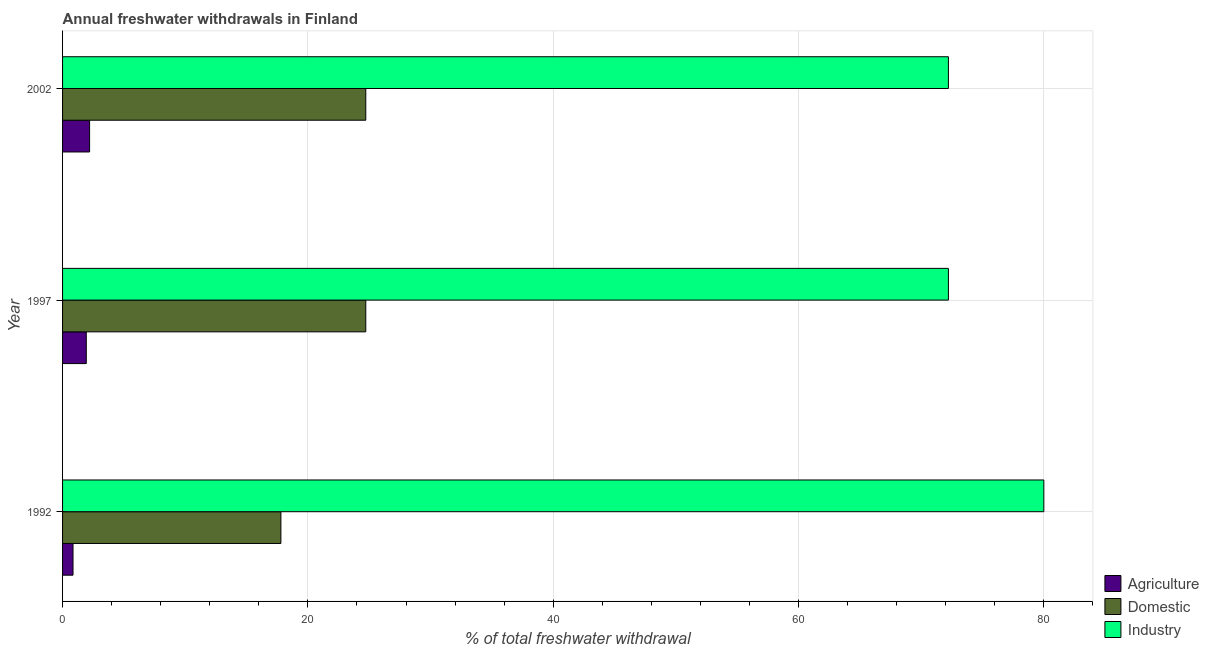How many different coloured bars are there?
Make the answer very short. 3. How many groups of bars are there?
Keep it short and to the point. 3. Are the number of bars on each tick of the Y-axis equal?
Your response must be concise. Yes. How many bars are there on the 1st tick from the top?
Offer a terse response. 3. How many bars are there on the 3rd tick from the bottom?
Give a very brief answer. 3. What is the label of the 1st group of bars from the top?
Provide a short and direct response. 2002. What is the percentage of freshwater withdrawal for agriculture in 1997?
Provide a short and direct response. 1.93. Across all years, what is the maximum percentage of freshwater withdrawal for agriculture?
Provide a succinct answer. 2.2. Across all years, what is the minimum percentage of freshwater withdrawal for domestic purposes?
Provide a short and direct response. 17.8. What is the total percentage of freshwater withdrawal for domestic purposes in the graph?
Offer a very short reply. 67.24. What is the difference between the percentage of freshwater withdrawal for agriculture in 1997 and that in 2002?
Give a very brief answer. -0.27. What is the difference between the percentage of freshwater withdrawal for domestic purposes in 1992 and the percentage of freshwater withdrawal for industry in 1997?
Provide a succinct answer. -54.42. What is the average percentage of freshwater withdrawal for agriculture per year?
Your answer should be very brief. 1.66. In the year 1997, what is the difference between the percentage of freshwater withdrawal for industry and percentage of freshwater withdrawal for domestic purposes?
Give a very brief answer. 47.5. In how many years, is the percentage of freshwater withdrawal for domestic purposes greater than 36 %?
Give a very brief answer. 0. What is the ratio of the percentage of freshwater withdrawal for agriculture in 1997 to that in 2002?
Your answer should be very brief. 0.88. Is the percentage of freshwater withdrawal for industry in 1992 less than that in 2002?
Your answer should be very brief. No. Is the difference between the percentage of freshwater withdrawal for domestic purposes in 1997 and 2002 greater than the difference between the percentage of freshwater withdrawal for industry in 1997 and 2002?
Your response must be concise. No. What is the difference between the highest and the lowest percentage of freshwater withdrawal for industry?
Provide a short and direct response. 7.78. In how many years, is the percentage of freshwater withdrawal for agriculture greater than the average percentage of freshwater withdrawal for agriculture taken over all years?
Keep it short and to the point. 2. Is the sum of the percentage of freshwater withdrawal for domestic purposes in 1992 and 2002 greater than the maximum percentage of freshwater withdrawal for industry across all years?
Keep it short and to the point. No. What does the 2nd bar from the top in 2002 represents?
Make the answer very short. Domestic. What does the 2nd bar from the bottom in 1992 represents?
Your answer should be compact. Domestic. Is it the case that in every year, the sum of the percentage of freshwater withdrawal for agriculture and percentage of freshwater withdrawal for domestic purposes is greater than the percentage of freshwater withdrawal for industry?
Provide a succinct answer. No. How many bars are there?
Your answer should be compact. 9. What is the difference between two consecutive major ticks on the X-axis?
Give a very brief answer. 20. Are the values on the major ticks of X-axis written in scientific E-notation?
Provide a short and direct response. No. How many legend labels are there?
Give a very brief answer. 3. How are the legend labels stacked?
Offer a very short reply. Vertical. What is the title of the graph?
Make the answer very short. Annual freshwater withdrawals in Finland. What is the label or title of the X-axis?
Provide a short and direct response. % of total freshwater withdrawal. What is the % of total freshwater withdrawal of Agriculture in 1992?
Make the answer very short. 0.85. What is the % of total freshwater withdrawal of Industry in 1992?
Offer a terse response. 80. What is the % of total freshwater withdrawal in Agriculture in 1997?
Give a very brief answer. 1.93. What is the % of total freshwater withdrawal of Domestic in 1997?
Your answer should be compact. 24.72. What is the % of total freshwater withdrawal of Industry in 1997?
Keep it short and to the point. 72.22. What is the % of total freshwater withdrawal of Agriculture in 2002?
Your answer should be compact. 2.2. What is the % of total freshwater withdrawal in Domestic in 2002?
Your answer should be compact. 24.72. What is the % of total freshwater withdrawal of Industry in 2002?
Keep it short and to the point. 72.22. Across all years, what is the maximum % of total freshwater withdrawal in Agriculture?
Ensure brevity in your answer.  2.2. Across all years, what is the maximum % of total freshwater withdrawal in Domestic?
Ensure brevity in your answer.  24.72. Across all years, what is the minimum % of total freshwater withdrawal of Agriculture?
Your answer should be compact. 0.85. Across all years, what is the minimum % of total freshwater withdrawal of Domestic?
Keep it short and to the point. 17.8. Across all years, what is the minimum % of total freshwater withdrawal in Industry?
Your answer should be compact. 72.22. What is the total % of total freshwater withdrawal of Agriculture in the graph?
Your answer should be compact. 4.99. What is the total % of total freshwater withdrawal of Domestic in the graph?
Keep it short and to the point. 67.24. What is the total % of total freshwater withdrawal of Industry in the graph?
Keep it short and to the point. 224.44. What is the difference between the % of total freshwater withdrawal of Agriculture in 1992 and that in 1997?
Ensure brevity in your answer.  -1.08. What is the difference between the % of total freshwater withdrawal of Domestic in 1992 and that in 1997?
Provide a succinct answer. -6.92. What is the difference between the % of total freshwater withdrawal of Industry in 1992 and that in 1997?
Provide a succinct answer. 7.78. What is the difference between the % of total freshwater withdrawal in Agriculture in 1992 and that in 2002?
Give a very brief answer. -1.35. What is the difference between the % of total freshwater withdrawal of Domestic in 1992 and that in 2002?
Your response must be concise. -6.92. What is the difference between the % of total freshwater withdrawal in Industry in 1992 and that in 2002?
Give a very brief answer. 7.78. What is the difference between the % of total freshwater withdrawal of Agriculture in 1997 and that in 2002?
Give a very brief answer. -0.27. What is the difference between the % of total freshwater withdrawal of Domestic in 1997 and that in 2002?
Offer a very short reply. 0. What is the difference between the % of total freshwater withdrawal of Industry in 1997 and that in 2002?
Your response must be concise. 0. What is the difference between the % of total freshwater withdrawal of Agriculture in 1992 and the % of total freshwater withdrawal of Domestic in 1997?
Offer a terse response. -23.87. What is the difference between the % of total freshwater withdrawal of Agriculture in 1992 and the % of total freshwater withdrawal of Industry in 1997?
Offer a very short reply. -71.37. What is the difference between the % of total freshwater withdrawal of Domestic in 1992 and the % of total freshwater withdrawal of Industry in 1997?
Offer a very short reply. -54.42. What is the difference between the % of total freshwater withdrawal of Agriculture in 1992 and the % of total freshwater withdrawal of Domestic in 2002?
Offer a very short reply. -23.87. What is the difference between the % of total freshwater withdrawal of Agriculture in 1992 and the % of total freshwater withdrawal of Industry in 2002?
Provide a short and direct response. -71.37. What is the difference between the % of total freshwater withdrawal of Domestic in 1992 and the % of total freshwater withdrawal of Industry in 2002?
Offer a very short reply. -54.42. What is the difference between the % of total freshwater withdrawal of Agriculture in 1997 and the % of total freshwater withdrawal of Domestic in 2002?
Provide a short and direct response. -22.79. What is the difference between the % of total freshwater withdrawal of Agriculture in 1997 and the % of total freshwater withdrawal of Industry in 2002?
Offer a very short reply. -70.29. What is the difference between the % of total freshwater withdrawal in Domestic in 1997 and the % of total freshwater withdrawal in Industry in 2002?
Your answer should be compact. -47.5. What is the average % of total freshwater withdrawal of Agriculture per year?
Give a very brief answer. 1.66. What is the average % of total freshwater withdrawal in Domestic per year?
Provide a succinct answer. 22.41. What is the average % of total freshwater withdrawal in Industry per year?
Provide a succinct answer. 74.81. In the year 1992, what is the difference between the % of total freshwater withdrawal in Agriculture and % of total freshwater withdrawal in Domestic?
Your answer should be compact. -16.95. In the year 1992, what is the difference between the % of total freshwater withdrawal of Agriculture and % of total freshwater withdrawal of Industry?
Give a very brief answer. -79.15. In the year 1992, what is the difference between the % of total freshwater withdrawal in Domestic and % of total freshwater withdrawal in Industry?
Your response must be concise. -62.2. In the year 1997, what is the difference between the % of total freshwater withdrawal of Agriculture and % of total freshwater withdrawal of Domestic?
Your answer should be compact. -22.79. In the year 1997, what is the difference between the % of total freshwater withdrawal of Agriculture and % of total freshwater withdrawal of Industry?
Offer a terse response. -70.29. In the year 1997, what is the difference between the % of total freshwater withdrawal of Domestic and % of total freshwater withdrawal of Industry?
Offer a terse response. -47.5. In the year 2002, what is the difference between the % of total freshwater withdrawal of Agriculture and % of total freshwater withdrawal of Domestic?
Make the answer very short. -22.52. In the year 2002, what is the difference between the % of total freshwater withdrawal of Agriculture and % of total freshwater withdrawal of Industry?
Your answer should be very brief. -70.02. In the year 2002, what is the difference between the % of total freshwater withdrawal in Domestic and % of total freshwater withdrawal in Industry?
Ensure brevity in your answer.  -47.5. What is the ratio of the % of total freshwater withdrawal of Agriculture in 1992 to that in 1997?
Offer a very short reply. 0.44. What is the ratio of the % of total freshwater withdrawal of Domestic in 1992 to that in 1997?
Ensure brevity in your answer.  0.72. What is the ratio of the % of total freshwater withdrawal of Industry in 1992 to that in 1997?
Provide a short and direct response. 1.11. What is the ratio of the % of total freshwater withdrawal in Agriculture in 1992 to that in 2002?
Keep it short and to the point. 0.39. What is the ratio of the % of total freshwater withdrawal in Domestic in 1992 to that in 2002?
Your answer should be very brief. 0.72. What is the ratio of the % of total freshwater withdrawal in Industry in 1992 to that in 2002?
Your answer should be very brief. 1.11. What is the ratio of the % of total freshwater withdrawal of Agriculture in 1997 to that in 2002?
Provide a succinct answer. 0.88. What is the ratio of the % of total freshwater withdrawal of Domestic in 1997 to that in 2002?
Offer a terse response. 1. What is the difference between the highest and the second highest % of total freshwater withdrawal in Agriculture?
Keep it short and to the point. 0.27. What is the difference between the highest and the second highest % of total freshwater withdrawal in Industry?
Provide a succinct answer. 7.78. What is the difference between the highest and the lowest % of total freshwater withdrawal of Agriculture?
Make the answer very short. 1.35. What is the difference between the highest and the lowest % of total freshwater withdrawal in Domestic?
Offer a very short reply. 6.92. What is the difference between the highest and the lowest % of total freshwater withdrawal of Industry?
Make the answer very short. 7.78. 